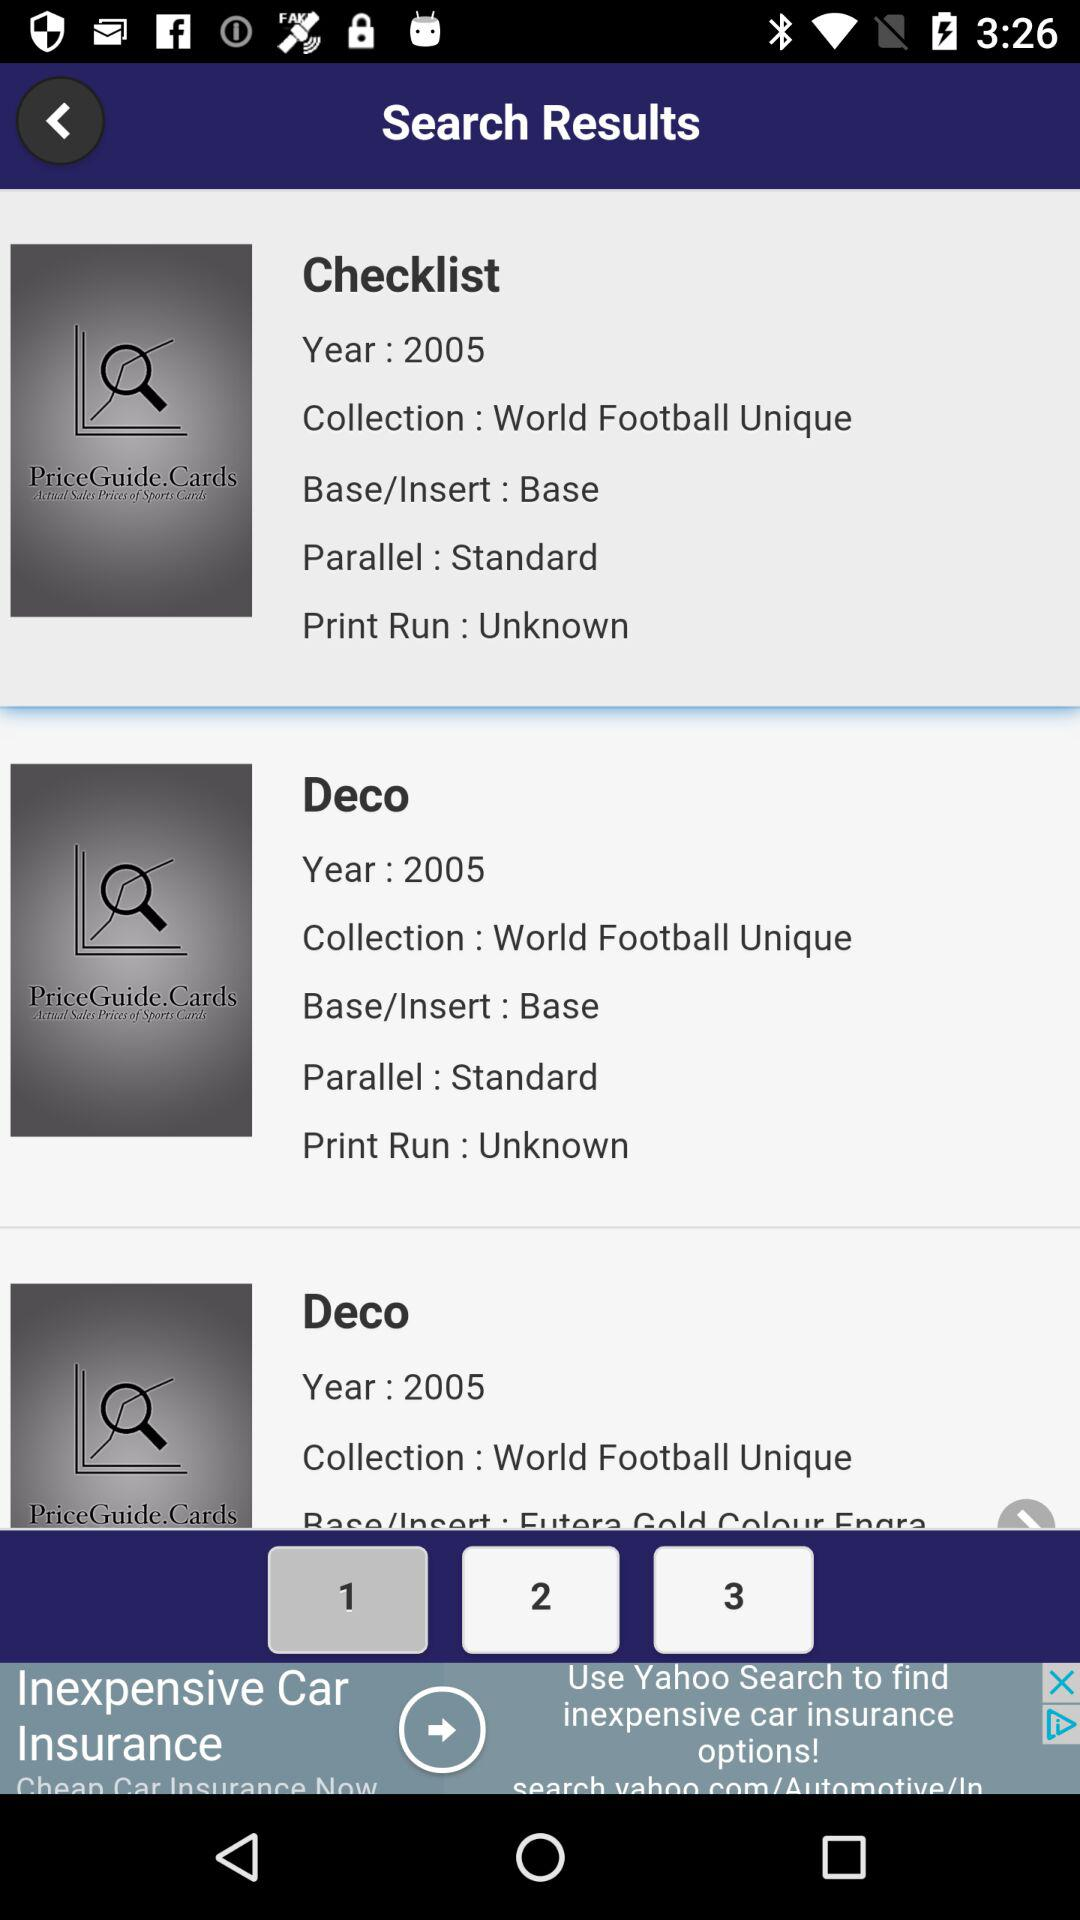What is the print run checklist? The print run checklist is "Unknown". 